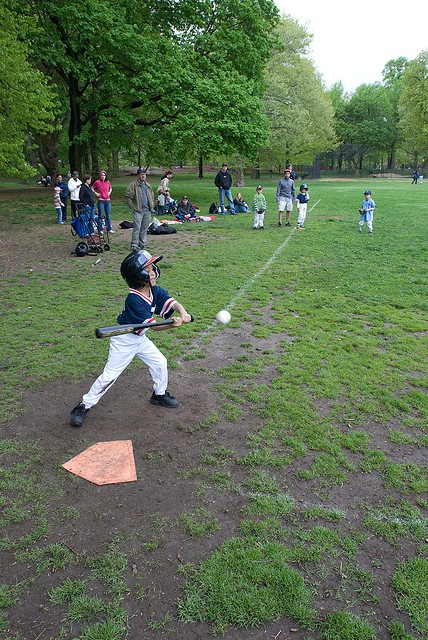Describe the objects in this image and their specific colors. I can see people in darkgreen, lavender, black, navy, and gray tones, people in darkgreen, green, gray, black, and lavender tones, people in darkgreen, gray, darkgray, and black tones, people in darkgreen, black, navy, purple, and blue tones, and baseball bat in darkgreen, black, and gray tones in this image. 